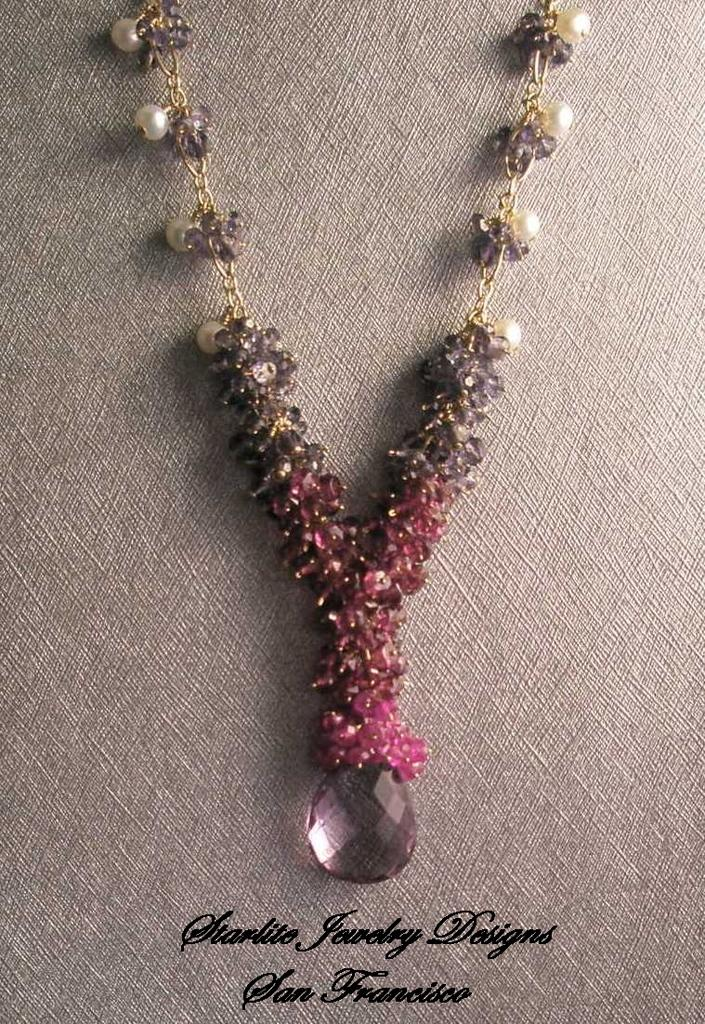What is present on the object in the image? There is a necklace in the image. Can you describe the position of the necklace in the image? The necklace is on an object. What additional information can be found at the bottom of the image? There is text visible at the bottom of the image. What type of polish is being applied to the necklace in the image? There is no polish being applied to the necklace in the image. Can you see a chess game being played in the image? There is no chess game visible in the image. 